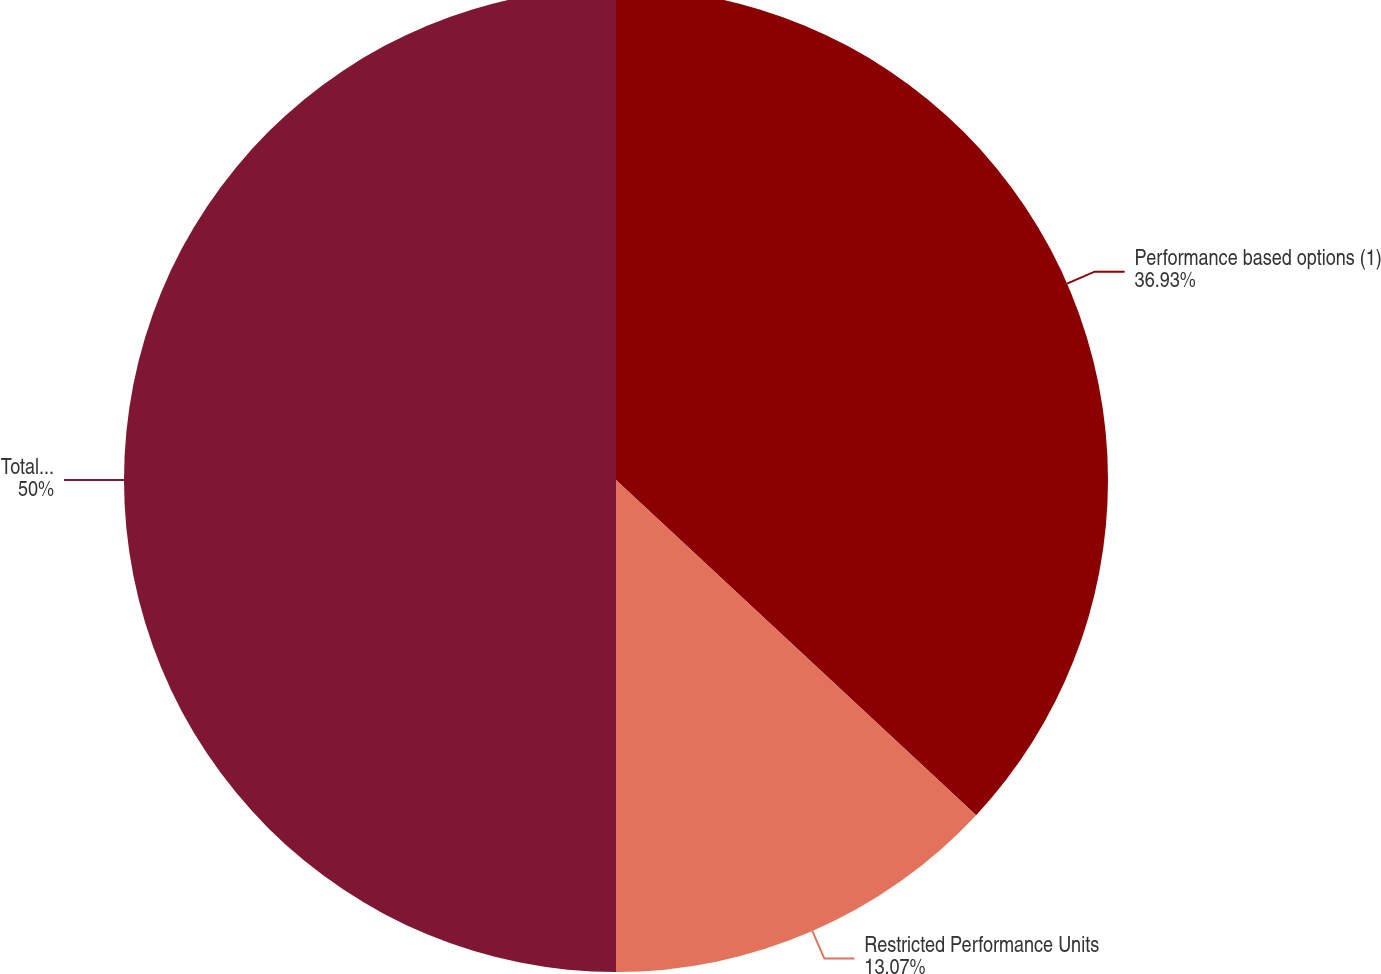Convert chart. <chart><loc_0><loc_0><loc_500><loc_500><pie_chart><fcel>Performance based options (1)<fcel>Restricted Performance Units<fcel>Total (1)<nl><fcel>36.93%<fcel>13.07%<fcel>50.0%<nl></chart> 